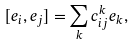Convert formula to latex. <formula><loc_0><loc_0><loc_500><loc_500>[ e _ { i } , e _ { j } ] = \sum _ { k } c _ { i j } ^ { k } e _ { k } ,</formula> 